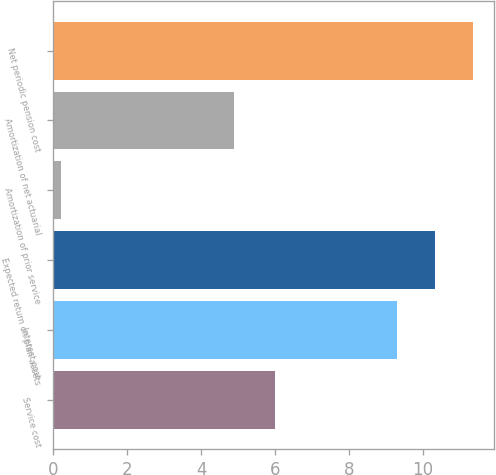<chart> <loc_0><loc_0><loc_500><loc_500><bar_chart><fcel>Service cost<fcel>Interest cost<fcel>Expected return on plan assets<fcel>Amortization of prior service<fcel>Amortization of net actuarial<fcel>Net periodic pension cost<nl><fcel>6<fcel>9.3<fcel>10.33<fcel>0.2<fcel>4.9<fcel>11.36<nl></chart> 